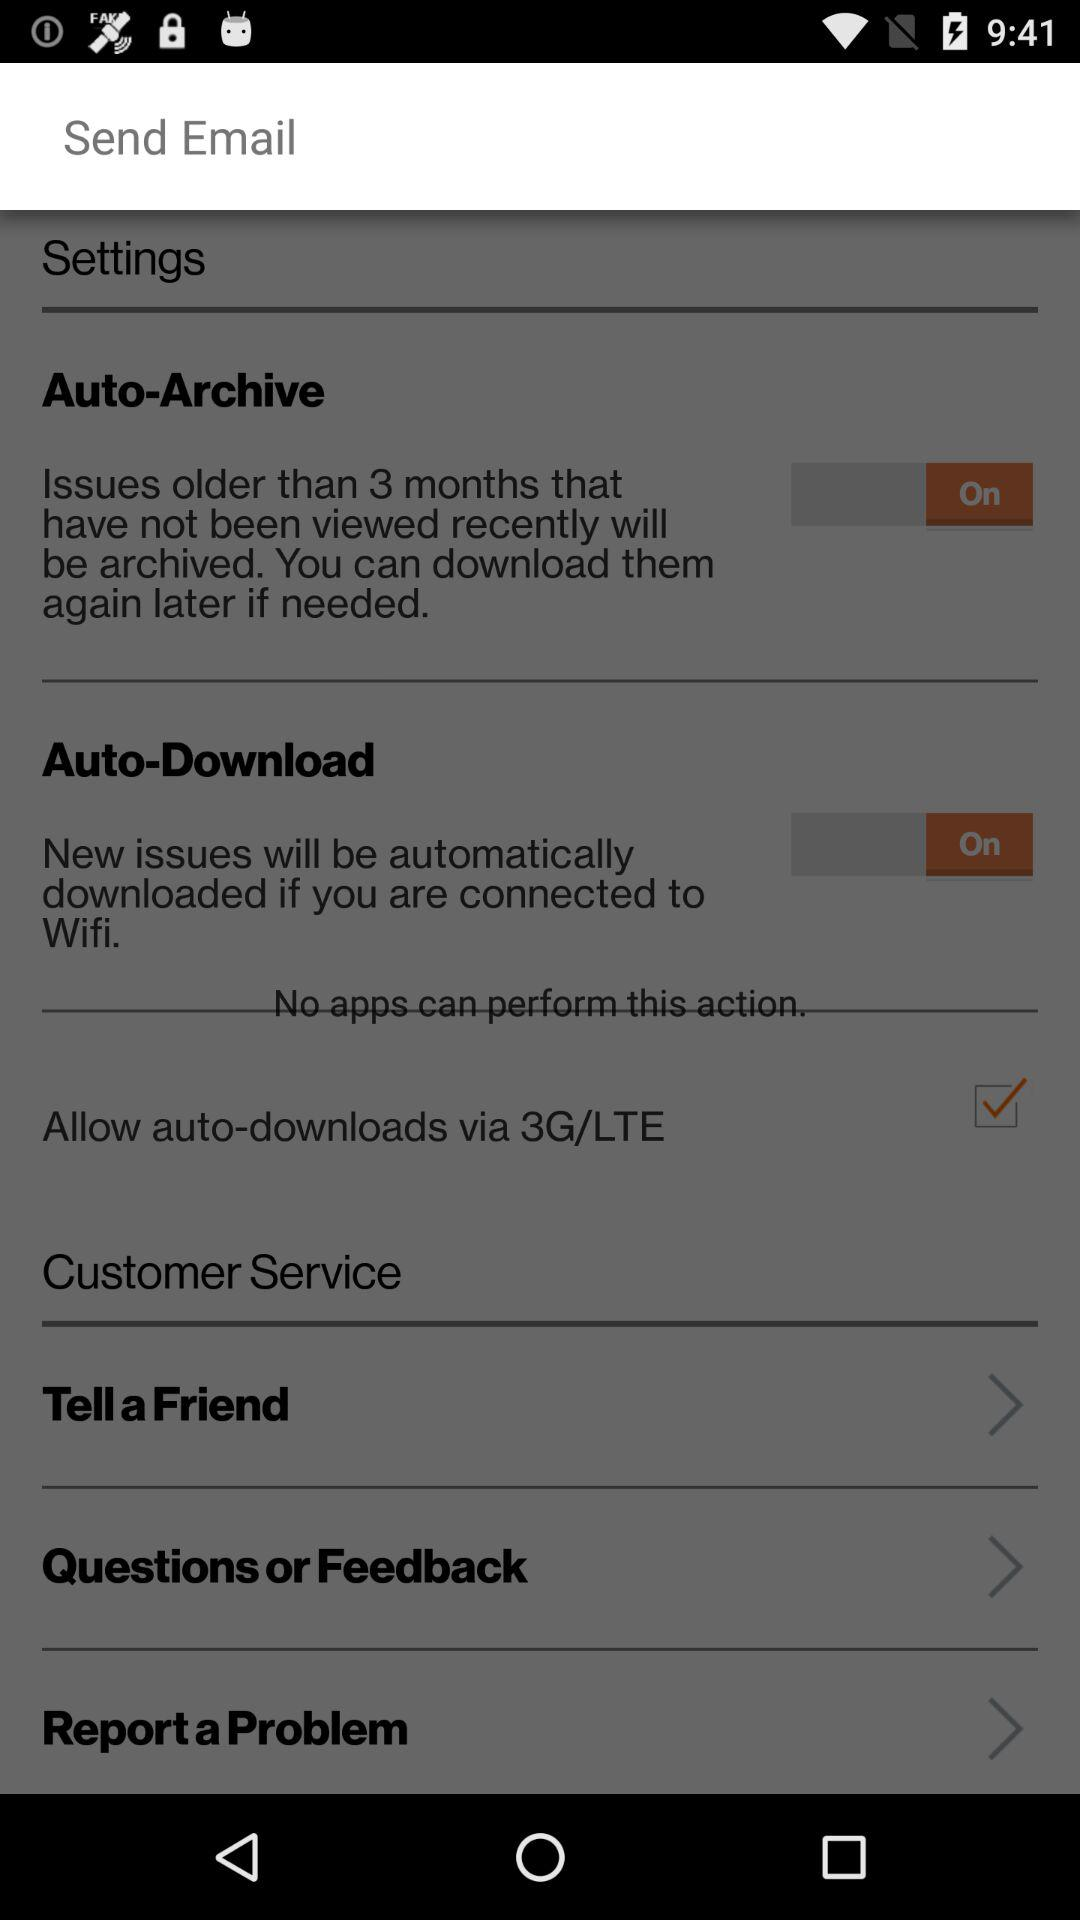How many months older issues will be archived? Issues older than 3 months will be archived. 